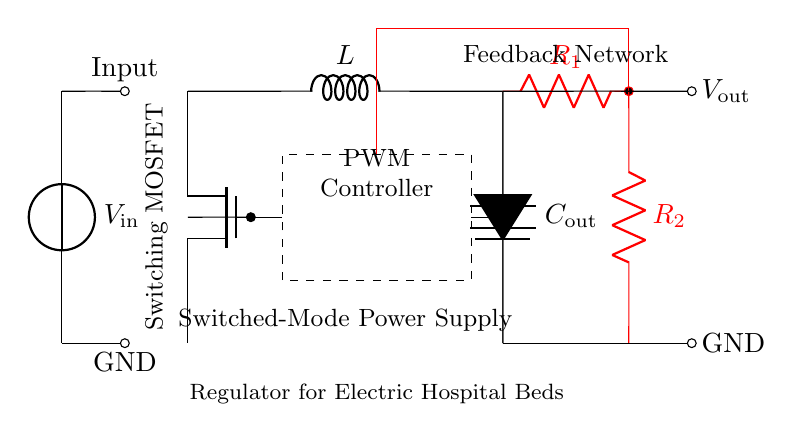What is the input voltage source of the circuit? The circuit diagram shows an input voltage source labeled as  \( V_{\text{in}} \) located at the left side of the diagram.
Answer: Input voltage source is \( V_{\text{in}} \) What component provides output stabilization? The component providing output stabilization is the capacitor labeled \( C_{\text{out}} \), which is connected to the output.
Answer: Capacitor \( C_{\text{out}} \) How many resistors are in the feedback network? The feedback network contains two resistors labeled \( R_1 \) and \( R_2 \), both of which are connected to the output side of the circuit.
Answer: Two resistors Which type of transistor is used in this circuit? The circuit uses a switching transistor, specifically a MOSFET, which is indicated as \( Tnmos \) in the diagram.
Answer: MOSFET What role does the PWM controller play in this circuit? The PWM controller creates a pulse-width modulation signal to control the switch (MOSFET), thereby regulating the voltage output based on feedback.
Answer: Voltage regulation How is the output voltage connected in the circuit? The output voltage \( V_{\text{out}} \) is connected directly from the point where the inductor and capacitor connect, showing the regulated voltage output of the circuit.
Answer: Directly from the inductor and capacitor connection 